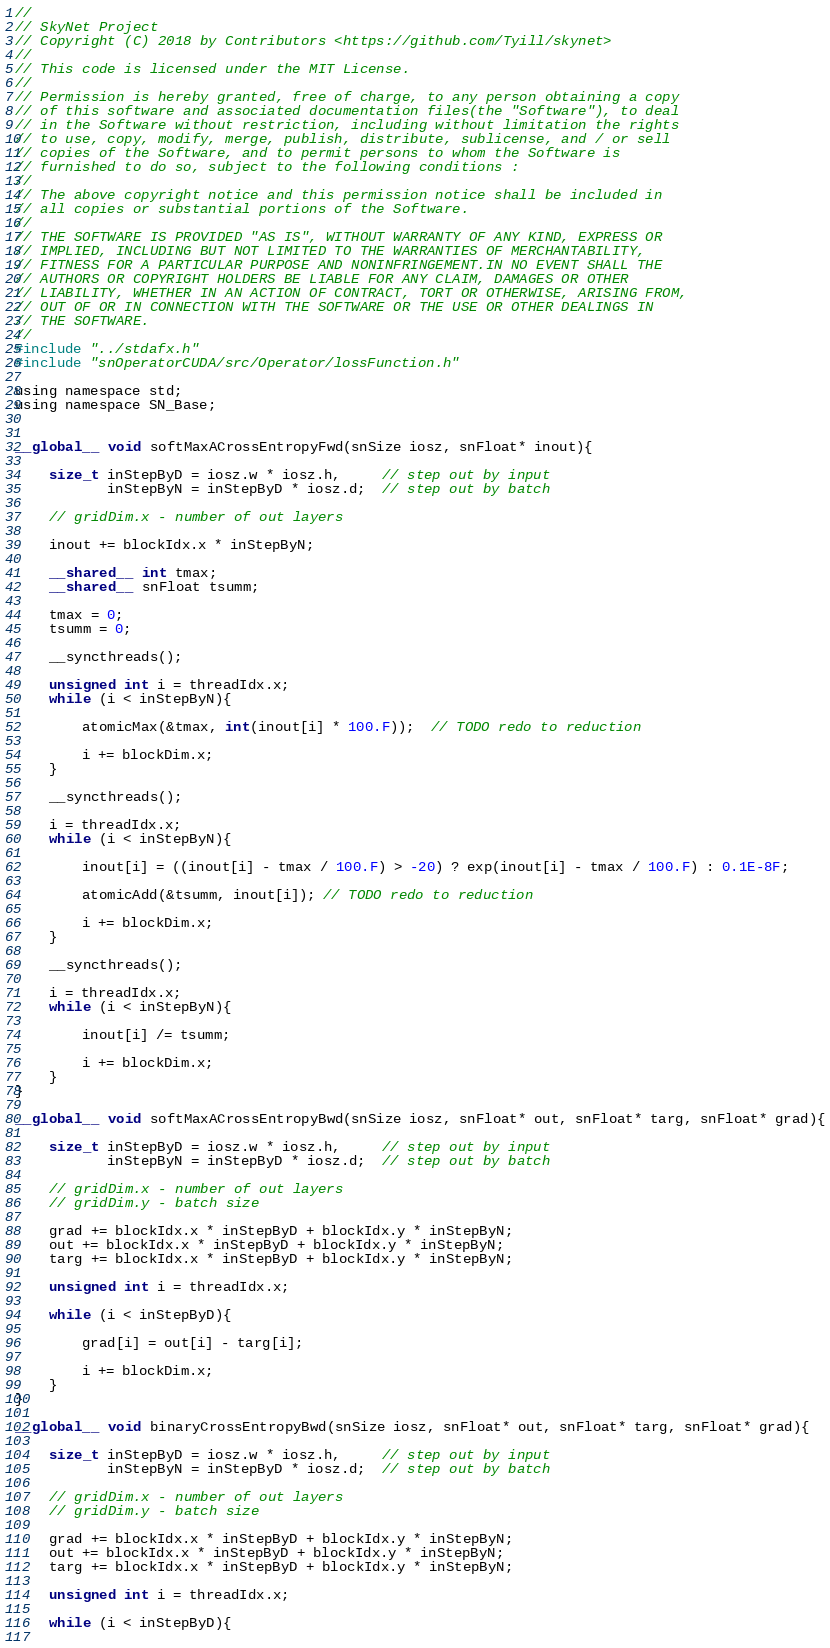<code> <loc_0><loc_0><loc_500><loc_500><_Cuda_>//
// SkyNet Project
// Copyright (C) 2018 by Contributors <https://github.com/Tyill/skynet>
//
// This code is licensed under the MIT License.
//
// Permission is hereby granted, free of charge, to any person obtaining a copy
// of this software and associated documentation files(the "Software"), to deal
// in the Software without restriction, including without limitation the rights
// to use, copy, modify, merge, publish, distribute, sublicense, and / or sell
// copies of the Software, and to permit persons to whom the Software is
// furnished to do so, subject to the following conditions :
//
// The above copyright notice and this permission notice shall be included in
// all copies or substantial portions of the Software.
//
// THE SOFTWARE IS PROVIDED "AS IS", WITHOUT WARRANTY OF ANY KIND, EXPRESS OR
// IMPLIED, INCLUDING BUT NOT LIMITED TO THE WARRANTIES OF MERCHANTABILITY,
// FITNESS FOR A PARTICULAR PURPOSE AND NONINFRINGEMENT.IN NO EVENT SHALL THE
// AUTHORS OR COPYRIGHT HOLDERS BE LIABLE FOR ANY CLAIM, DAMAGES OR OTHER
// LIABILITY, WHETHER IN AN ACTION OF CONTRACT, TORT OR OTHERWISE, ARISING FROM,
// OUT OF OR IN CONNECTION WITH THE SOFTWARE OR THE USE OR OTHER DEALINGS IN
// THE SOFTWARE.
//
#include "../stdafx.h"
#include "snOperatorCUDA/src/Operator/lossFunction.h"

using namespace std;
using namespace SN_Base;


__global__ void softMaxACrossEntropyFwd(snSize iosz, snFloat* inout){
      
    size_t inStepByD = iosz.w * iosz.h,     // step out by input
           inStepByN = inStepByD * iosz.d;  // step out by batch       

    // gridDim.x - number of out layers
 
    inout += blockIdx.x * inStepByN;
           
    __shared__ int tmax;
    __shared__ snFloat tsumm;

    tmax = 0;
    tsumm = 0;

    __syncthreads();

    unsigned int i = threadIdx.x;
    while (i < inStepByN){

        atomicMax(&tmax, int(inout[i] * 100.F));  // TODO redo to reduction
       
        i += blockDim.x;
    }
   
    __syncthreads();

    i = threadIdx.x;
    while (i < inStepByN){
       
        inout[i] = ((inout[i] - tmax / 100.F) > -20) ? exp(inout[i] - tmax / 100.F) : 0.1E-8F;
                 
        atomicAdd(&tsumm, inout[i]); // TODO redo to reduction

        i += blockDim.x;
    }
  
    __syncthreads();
   
    i = threadIdx.x;
    while (i < inStepByN){

        inout[i] /= tsumm;

        i += blockDim.x;
    }   
}

__global__ void softMaxACrossEntropyBwd(snSize iosz, snFloat* out, snFloat* targ, snFloat* grad){

    size_t inStepByD = iosz.w * iosz.h,     // step out by input
           inStepByN = inStepByD * iosz.d;  // step out by batch       

    // gridDim.x - number of out layers
    // gridDim.y - batch size  
    
    grad += blockIdx.x * inStepByD + blockIdx.y * inStepByN;
    out += blockIdx.x * inStepByD + blockIdx.y * inStepByN;
    targ += blockIdx.x * inStepByD + blockIdx.y * inStepByN;

    unsigned int i = threadIdx.x;

    while (i < inStepByD){

        grad[i] = out[i] - targ[i];

        i += blockDim.x;
    } 
}

__global__ void binaryCrossEntropyBwd(snSize iosz, snFloat* out, snFloat* targ, snFloat* grad){

    size_t inStepByD = iosz.w * iosz.h,     // step out by input
           inStepByN = inStepByD * iosz.d;  // step out by batch       

    // gridDim.x - number of out layers
    // gridDim.y - batch size  

    grad += blockIdx.x * inStepByD + blockIdx.y * inStepByN;
    out += blockIdx.x * inStepByD + blockIdx.y * inStepByN;
    targ += blockIdx.x * inStepByD + blockIdx.y * inStepByN;

    unsigned int i = threadIdx.x;

    while (i < inStepByD){
        </code> 